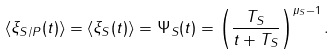Convert formula to latex. <formula><loc_0><loc_0><loc_500><loc_500>\langle \xi _ { S / P } ( t ) \rangle = \langle \xi _ { S } ( t ) \rangle = \Psi _ { S } ( t ) = \left ( \frac { T _ { S } } { t + T _ { S } } \right ) ^ { \mu _ { S } - 1 } .</formula> 